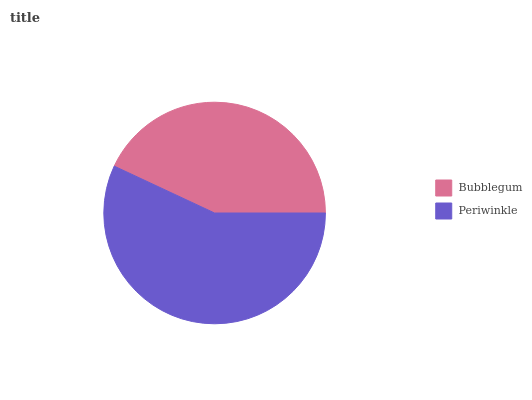Is Bubblegum the minimum?
Answer yes or no. Yes. Is Periwinkle the maximum?
Answer yes or no. Yes. Is Periwinkle the minimum?
Answer yes or no. No. Is Periwinkle greater than Bubblegum?
Answer yes or no. Yes. Is Bubblegum less than Periwinkle?
Answer yes or no. Yes. Is Bubblegum greater than Periwinkle?
Answer yes or no. No. Is Periwinkle less than Bubblegum?
Answer yes or no. No. Is Periwinkle the high median?
Answer yes or no. Yes. Is Bubblegum the low median?
Answer yes or no. Yes. Is Bubblegum the high median?
Answer yes or no. No. Is Periwinkle the low median?
Answer yes or no. No. 